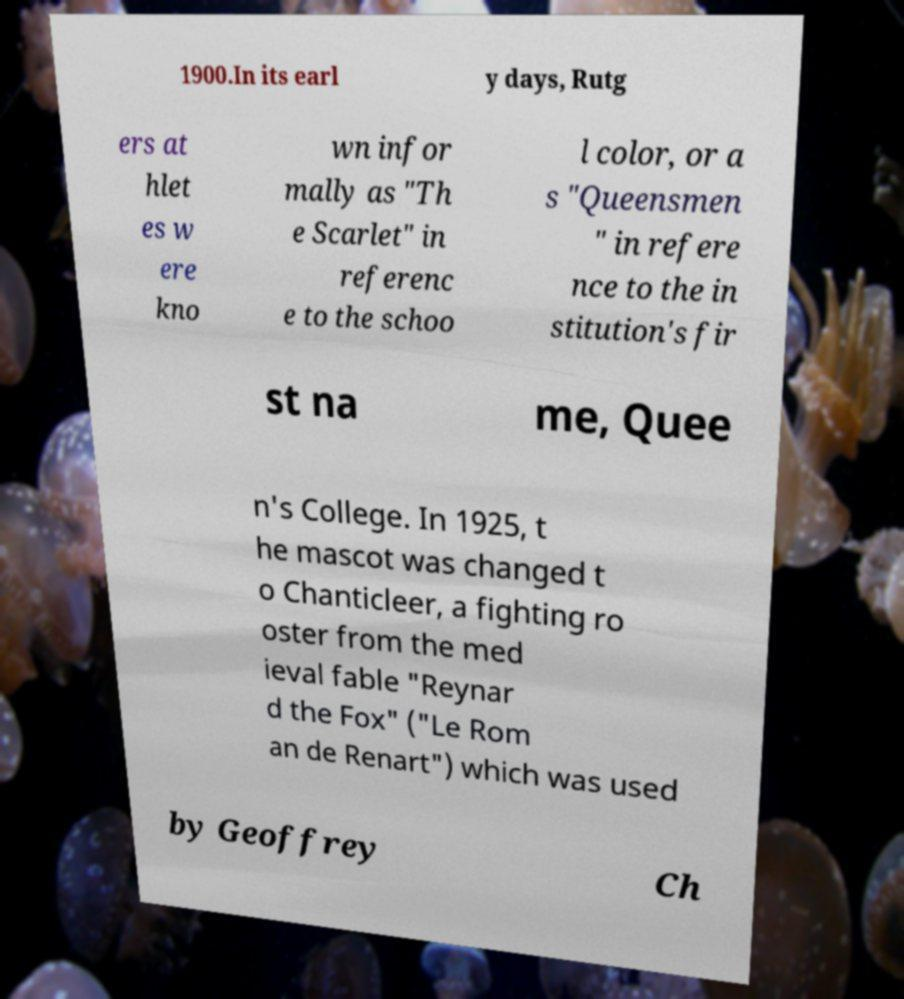Could you assist in decoding the text presented in this image and type it out clearly? 1900.In its earl y days, Rutg ers at hlet es w ere kno wn infor mally as "Th e Scarlet" in referenc e to the schoo l color, or a s "Queensmen " in refere nce to the in stitution's fir st na me, Quee n's College. In 1925, t he mascot was changed t o Chanticleer, a fighting ro oster from the med ieval fable "Reynar d the Fox" ("Le Rom an de Renart") which was used by Geoffrey Ch 